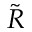Convert formula to latex. <formula><loc_0><loc_0><loc_500><loc_500>\tilde { R }</formula> 